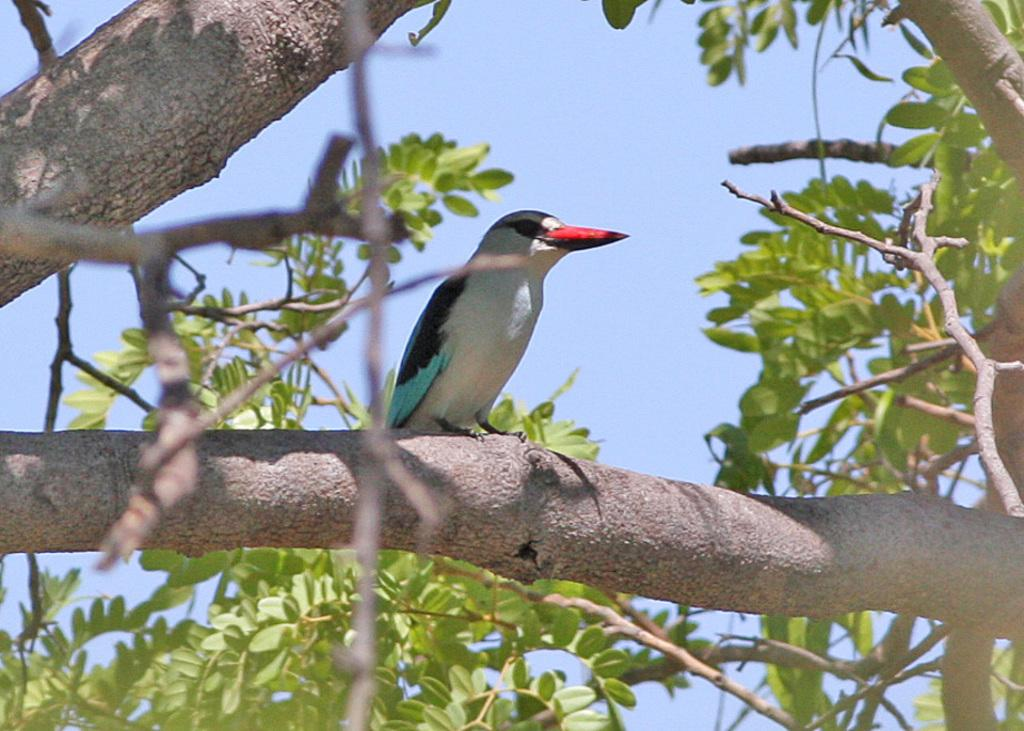What is one of the main subjects in the picture? There is a tree in the picture. What other living creature can be seen in the picture? There is a bird in the picture. What is the color of the bird? The bird is white in color. What are the colors of the bird's wings? The bird has black and blue wings. What is the color of the bird's beak? The bird has a red beak. How does the texture of the bird's feathers compare to the texture of the tree's bark? The provided facts do not mention the texture of the bird's feathers or the tree's bark, so it is not possible to make a comparison. 